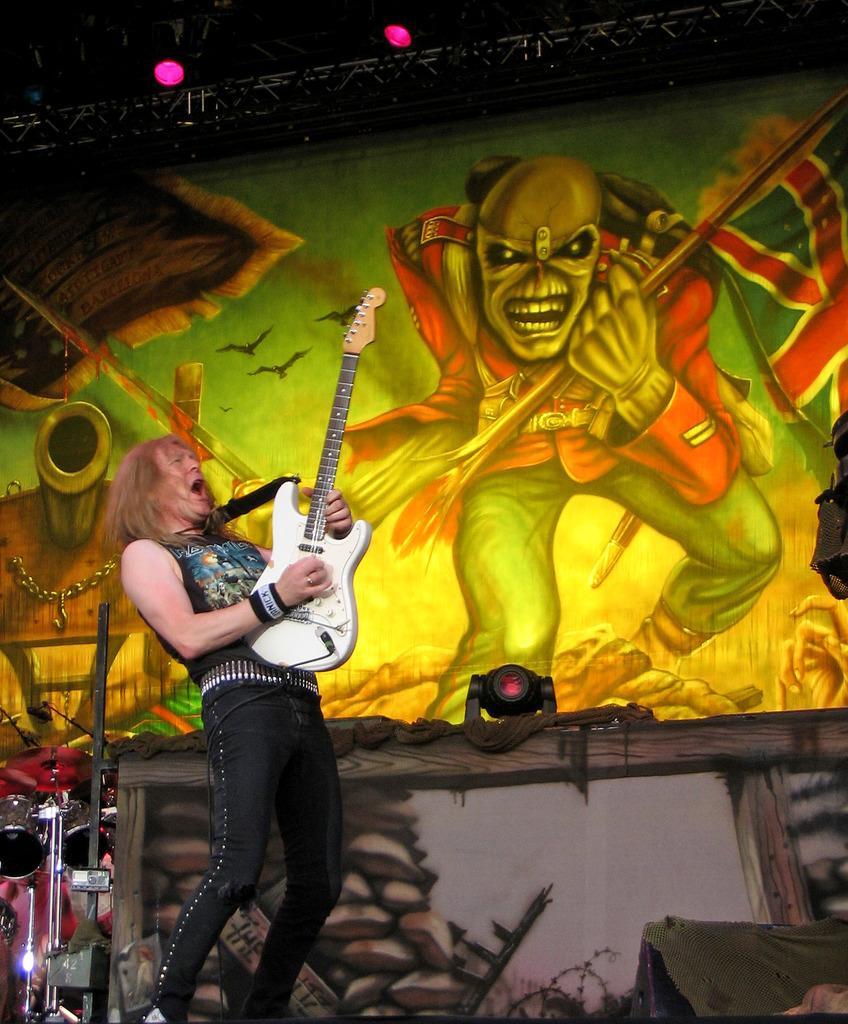How would you summarize this image in a sentence or two? In a picture there is one person standing and playing a guitar. The guitar is in white colour and he is wearing black dress and behind him there are drums and there is a big poster where in the poster there is one person is holding a flag. 